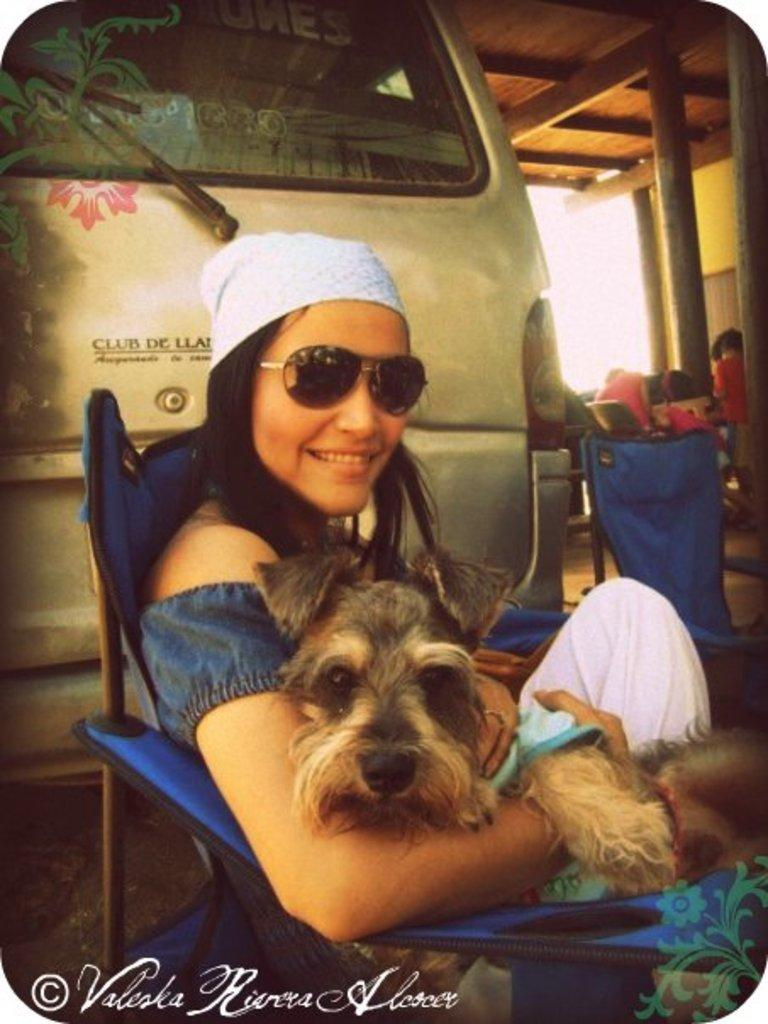Who is present in the image? There is a woman in the image. What is the woman doing in the image? The woman is sitting on a chair. What is the woman wearing on her face? The woman is wearing goggles. What is the woman wearing on her head? The woman is wearing a kerchief on her head. What is the woman holding in the image? The woman is holding a dog. What can be seen in the background of the image? There is a car visible in the background of the image. What type of carpentry tools can be seen in the woman's hands in the image? There are no carpentry tools visible in the woman's hands in the image. What kind of art is the woman creating in the image? There is no art creation depicted in the image; the woman is holding a dog. 